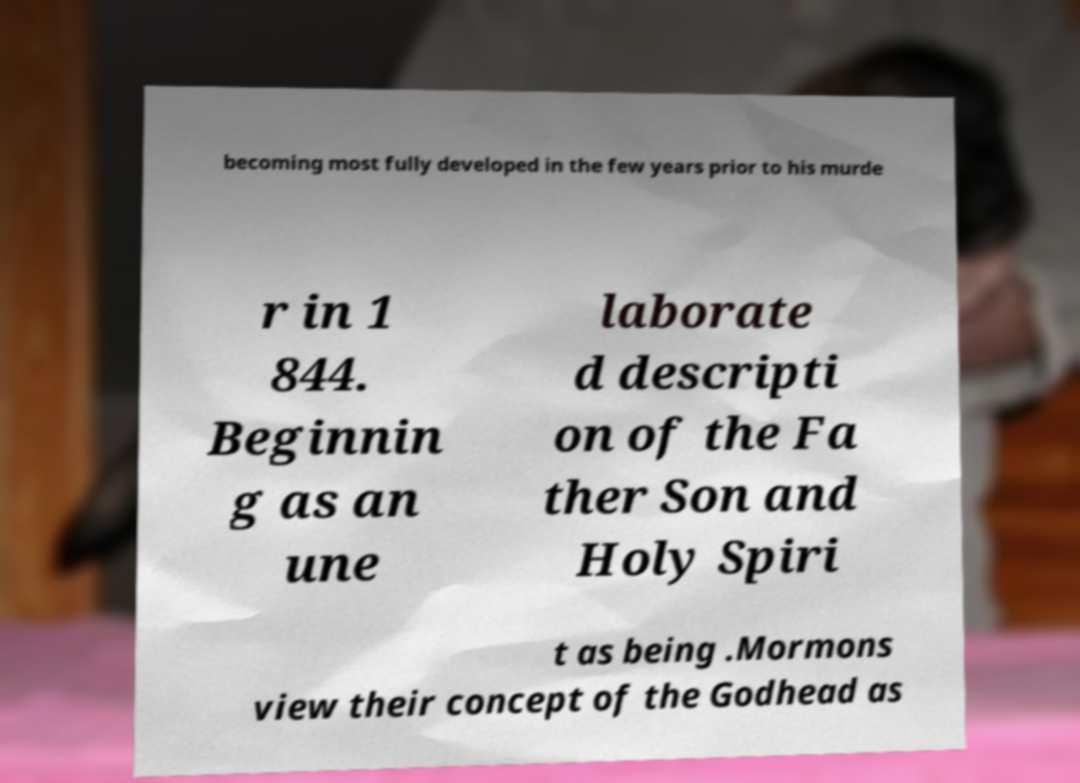I need the written content from this picture converted into text. Can you do that? becoming most fully developed in the few years prior to his murde r in 1 844. Beginnin g as an une laborate d descripti on of the Fa ther Son and Holy Spiri t as being .Mormons view their concept of the Godhead as 